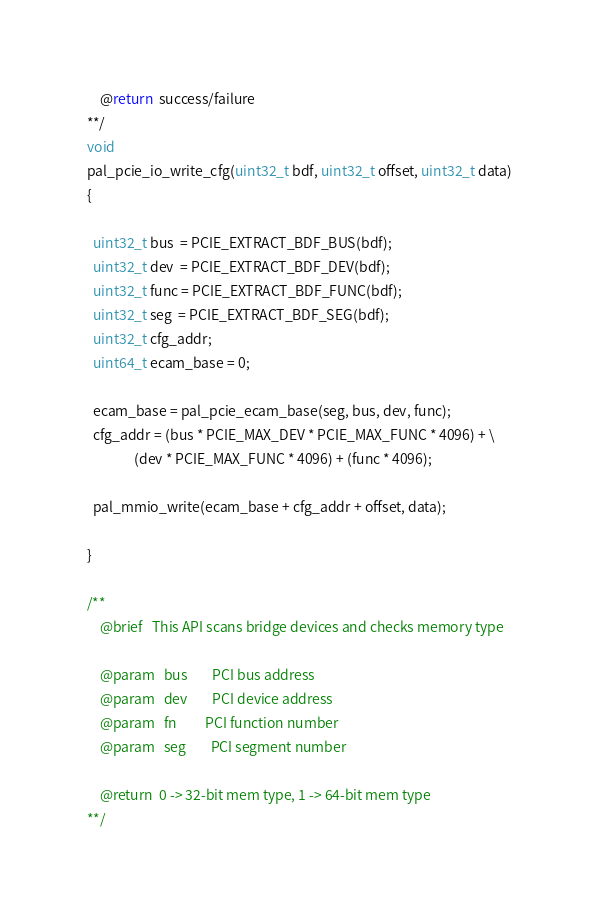Convert code to text. <code><loc_0><loc_0><loc_500><loc_500><_C_>    @return  success/failure
**/
void
pal_pcie_io_write_cfg(uint32_t bdf, uint32_t offset, uint32_t data)
{

  uint32_t bus  = PCIE_EXTRACT_BDF_BUS(bdf);
  uint32_t dev  = PCIE_EXTRACT_BDF_DEV(bdf);
  uint32_t func = PCIE_EXTRACT_BDF_FUNC(bdf);
  uint32_t seg  = PCIE_EXTRACT_BDF_SEG(bdf);
  uint32_t cfg_addr;
  uint64_t ecam_base = 0;

  ecam_base = pal_pcie_ecam_base(seg, bus, dev, func);
  cfg_addr = (bus * PCIE_MAX_DEV * PCIE_MAX_FUNC * 4096) + \
               (dev * PCIE_MAX_FUNC * 4096) + (func * 4096);

  pal_mmio_write(ecam_base + cfg_addr + offset, data);

}

/**
    @brief   This API scans bridge devices and checks memory type

    @param   bus        PCI bus address
    @param   dev        PCI device address
    @param   fn         PCI function number
    @param   seg        PCI segment number

    @return  0 -> 32-bit mem type, 1 -> 64-bit mem type
**/</code> 